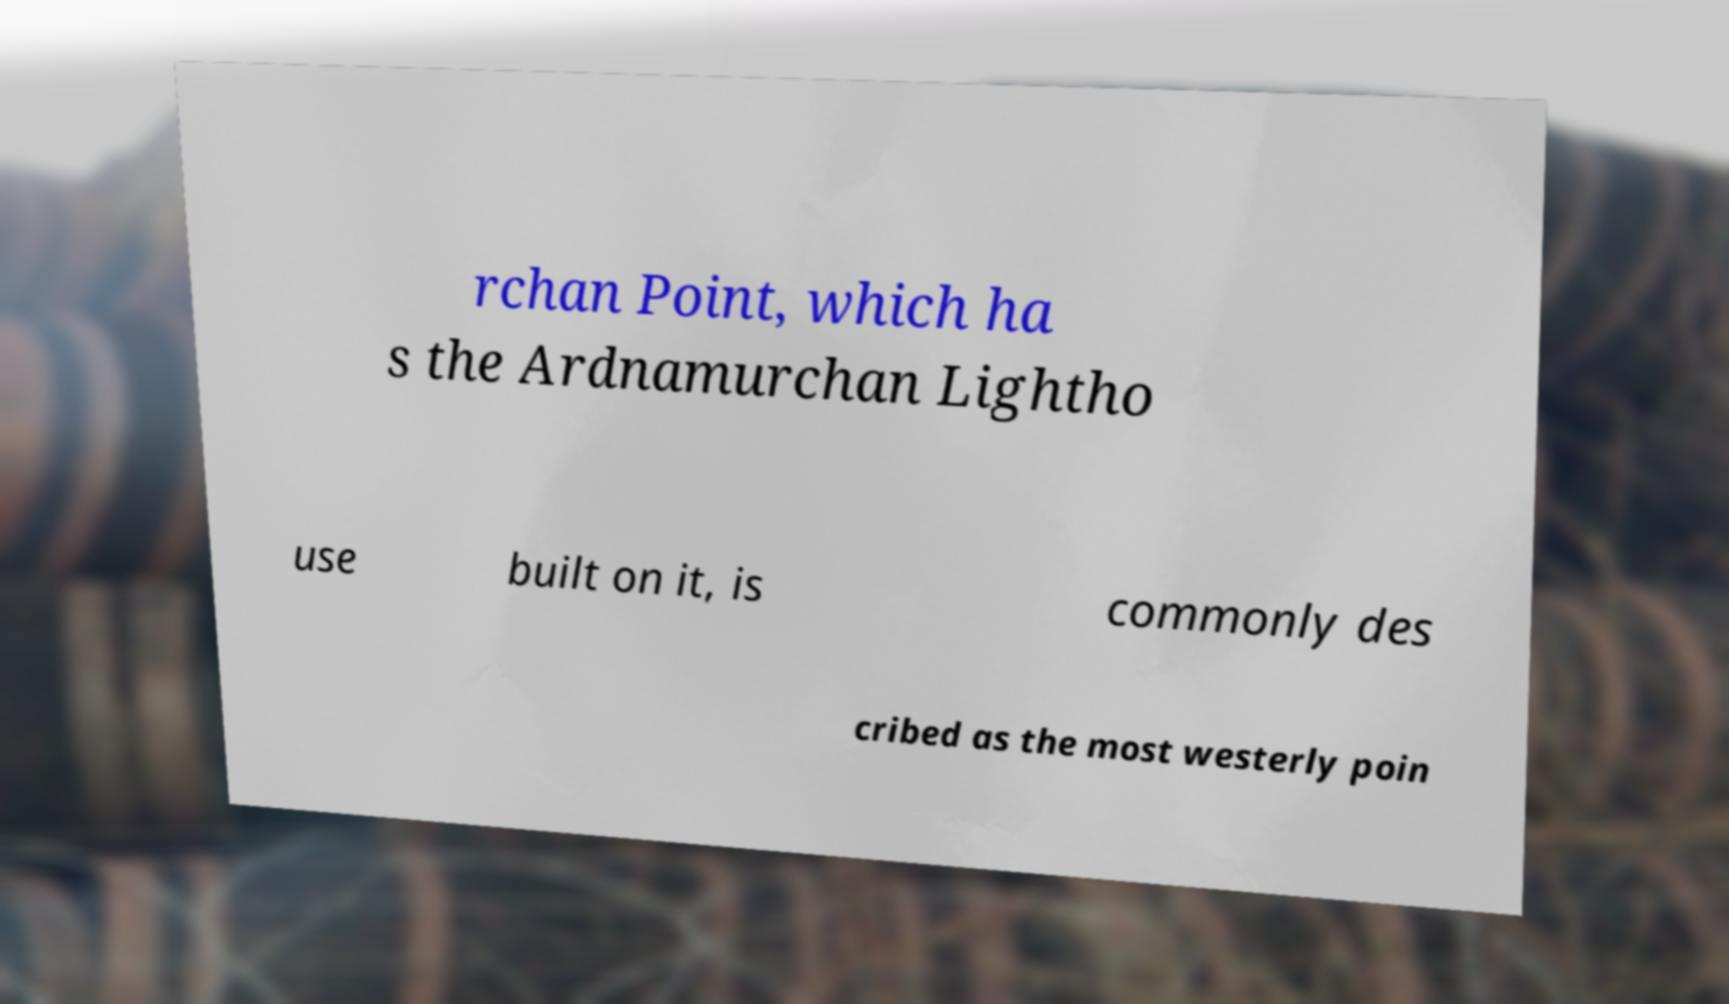Can you accurately transcribe the text from the provided image for me? rchan Point, which ha s the Ardnamurchan Lightho use built on it, is commonly des cribed as the most westerly poin 